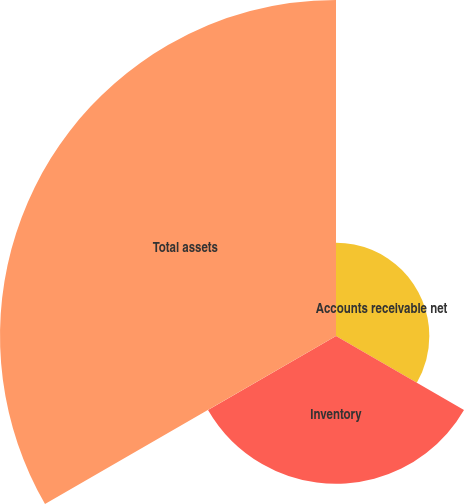<chart> <loc_0><loc_0><loc_500><loc_500><pie_chart><fcel>Accounts receivable net<fcel>Inventory<fcel>Total assets<nl><fcel>16.17%<fcel>25.61%<fcel>58.22%<nl></chart> 